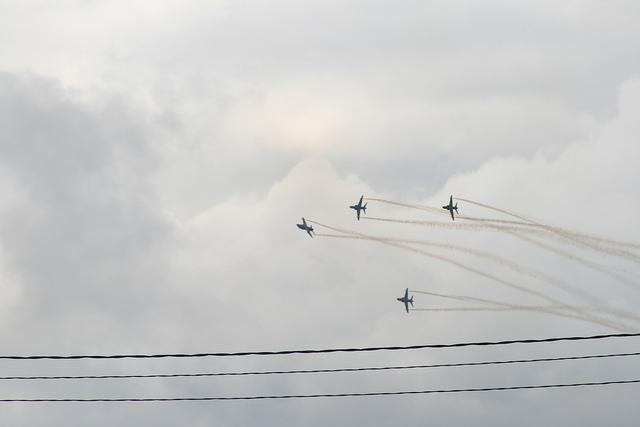What are these planes doing?
Answer briefly. Flying. What maneuver have the planes just executed?
Concise answer only. Roll. Are the planes in danger of hitting the wires?
Short answer required. No. 